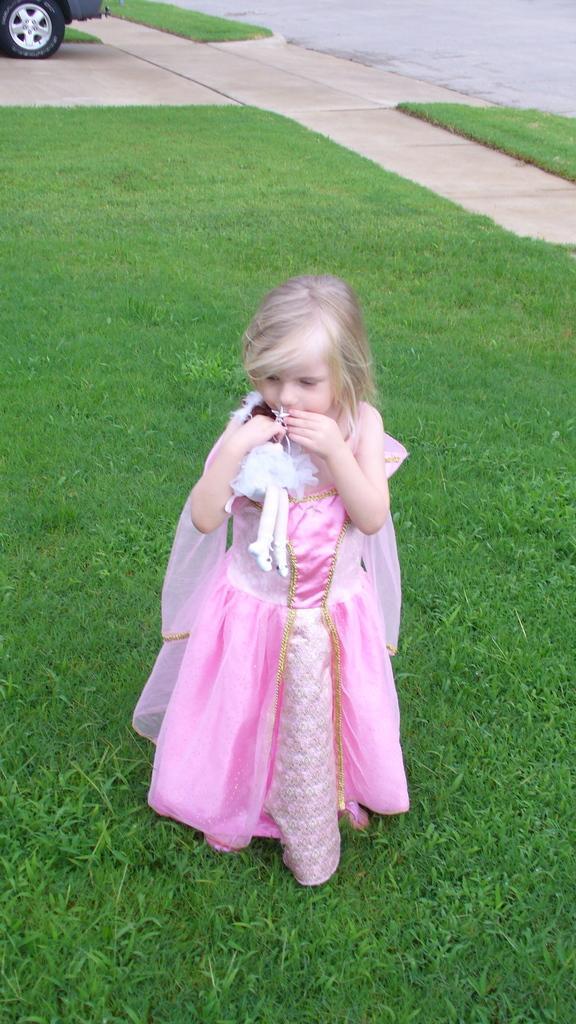Can you describe this image briefly? In this picture I can see a girl standing in front and I see that she is wearing pink color costume and I can also see that she is holding a toy and I see that she is standing on the grass. In the background I can see the path and I can see a vehicle on the top left corner of this picture. 